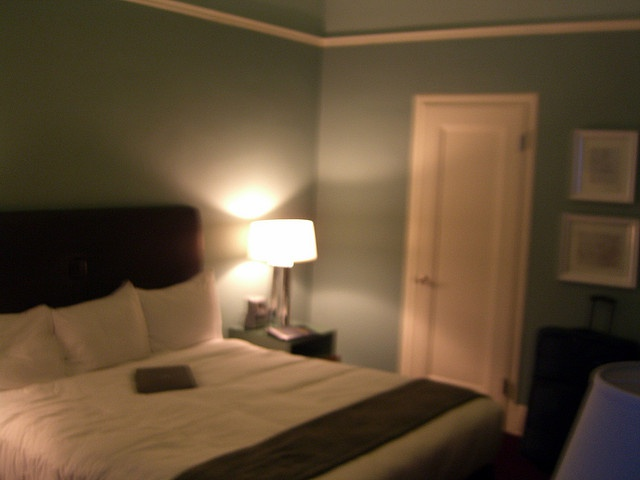Describe the objects in this image and their specific colors. I can see bed in black, gray, and brown tones, suitcase in black tones, and book in black and maroon tones in this image. 